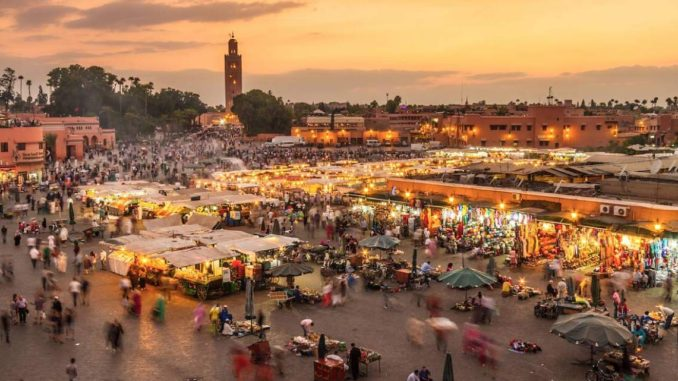Describe a short realistic scenario of a visitor exploring the marketplace. A visitor meanders through Jemaa El Fnaa, intrigued by the array of stalls. He stops at a spice vendor, the vivid colors and strong aromas drawing him in. After sharegpt4v/sampling a few blends, he moves on, enticed by the scent of grilled meats from a food stall. With a freshly made kebab in hand, he finds a small rug vendor and admires the intricate patterns, briefly negotiating with the vendor before purchasing a small, beautifully woven piece. As he moves towards the center of the square, he takes in the lively performances and pauses to watch a snake charmer captivating a small crowd. 